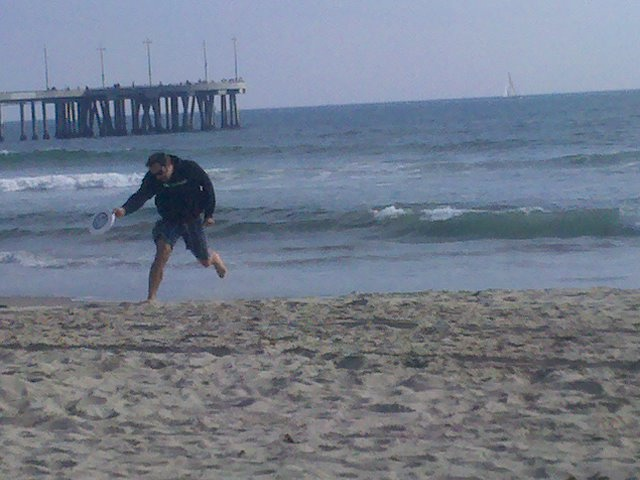Describe the objects in this image and their specific colors. I can see people in darkgray, black, gray, and darkblue tones, boat in darkgray and gray tones, frisbee in darkgray, gray, and blue tones, and boat in darkgray and gray tones in this image. 